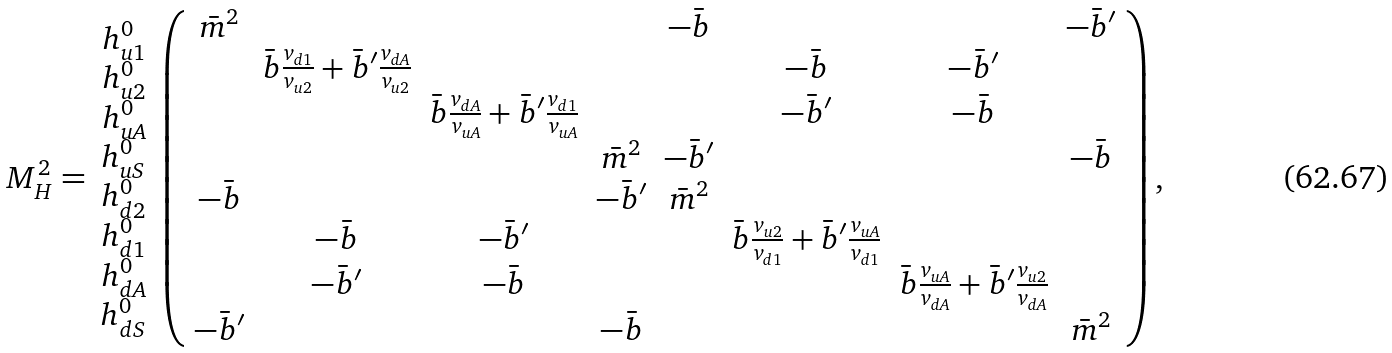<formula> <loc_0><loc_0><loc_500><loc_500>M _ { H } ^ { 2 } = \begin{array} { c } h ^ { 0 } _ { u 1 } \\ h ^ { 0 } _ { u 2 } \\ h ^ { 0 } _ { u A } \\ h ^ { 0 } _ { u S } \\ h ^ { 0 } _ { d 2 } \\ h ^ { 0 } _ { d 1 } \\ h ^ { 0 } _ { d A } \\ h ^ { 0 } _ { d S } \end{array} \left ( \begin{array} { c c c c c c c c } \bar { m } ^ { 2 } & & & & - \bar { b } & & & - \bar { b } ^ { \prime } \\ & \bar { b } \frac { v _ { d 1 } } { v _ { u 2 } } + \bar { b } ^ { \prime } \frac { v _ { d A } } { v _ { u 2 } } & & & & - \bar { b } & - \bar { b } ^ { \prime } & \\ & & \bar { b } \frac { v _ { d A } } { v _ { u A } } + \bar { b } ^ { \prime } \frac { v _ { d 1 } } { v _ { u A } } & & & - \bar { b } ^ { \prime } & - \bar { b } & \\ & & & \bar { m } ^ { 2 } & - \bar { b } ^ { \prime } & & & - \bar { b } \\ - \bar { b } & & & - \bar { b } ^ { \prime } & \bar { m } ^ { 2 } & & & \\ & - \bar { b } & - \bar { b } ^ { \prime } & & & \bar { b } \frac { v _ { u 2 } } { v _ { d 1 } } + \bar { b } ^ { \prime } \frac { v _ { u A } } { v _ { d 1 } } & & \\ & - \bar { b } ^ { \prime } & - \bar { b } & & & & \bar { b } \frac { v _ { u A } } { v _ { d A } } + \bar { b } ^ { \prime } \frac { v _ { u 2 } } { v _ { d A } } & \\ - \bar { b } ^ { \prime } & & & - \bar { b } & & & & \bar { m } ^ { 2 } \end{array} \right ) ,</formula> 